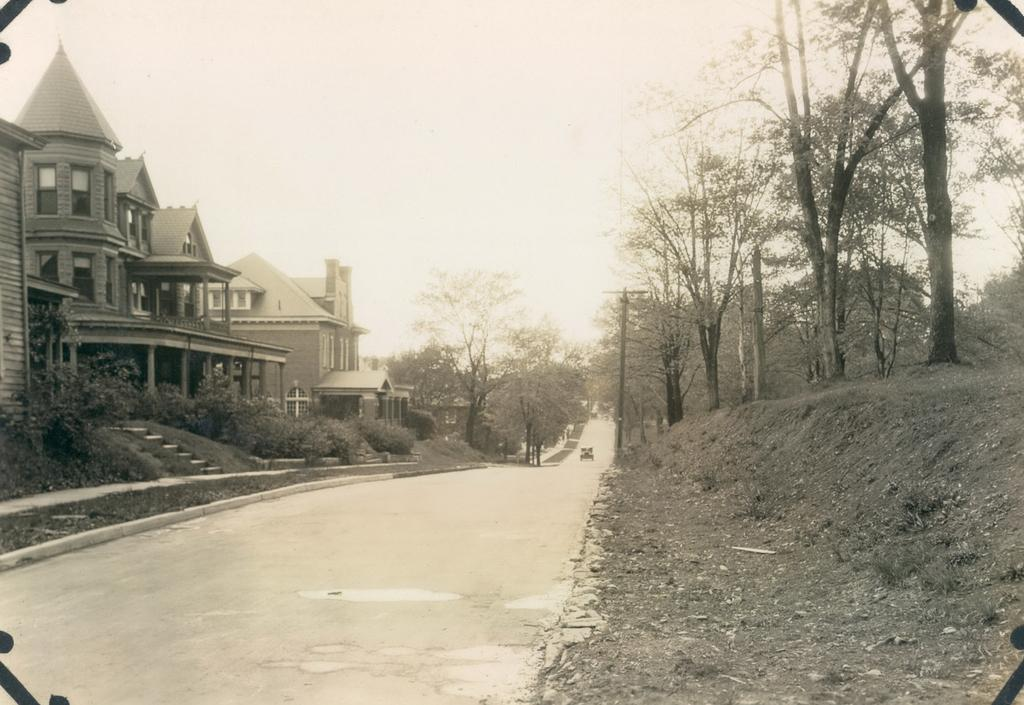What can be seen in the image that people can walk on? There is a path in the image that people can walk on. What structures are visible in the image? There are buildings in the image. What type of vegetation can be seen in the image? There are plants and trees in the image. How many trees are visible in the background? There are more trees visible in the background. What object can be seen in the background near the trees? There is a pole in the background. What type of vehicle can be seen in the background? There is a car on the road in the background. What part of the natural environment is visible in the background? The sky is visible in the background. Can you see a crown on the car in the image? There is no crown present on the car in the image. What type of request can be seen being made by the plants in the image? There are no requests being made by the plants in the image, as plants do not have the ability to make requests. 